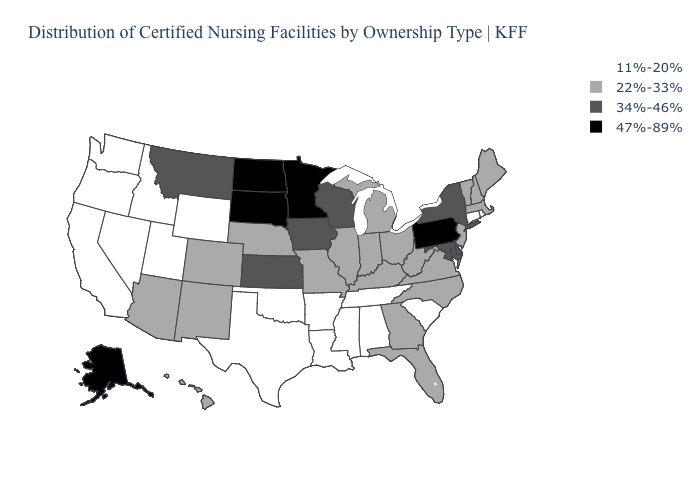What is the value of Nebraska?
Answer briefly. 22%-33%. Which states hav the highest value in the MidWest?
Answer briefly. Minnesota, North Dakota, South Dakota. What is the value of Kansas?
Answer briefly. 34%-46%. Among the states that border Ohio , which have the lowest value?
Concise answer only. Indiana, Kentucky, Michigan, West Virginia. What is the highest value in the West ?
Be succinct. 47%-89%. Name the states that have a value in the range 47%-89%?
Short answer required. Alaska, Minnesota, North Dakota, Pennsylvania, South Dakota. Does Utah have a lower value than Rhode Island?
Short answer required. No. Which states have the lowest value in the South?
Give a very brief answer. Alabama, Arkansas, Louisiana, Mississippi, Oklahoma, South Carolina, Tennessee, Texas. What is the highest value in states that border Massachusetts?
Give a very brief answer. 34%-46%. Name the states that have a value in the range 34%-46%?
Be succinct. Delaware, Iowa, Kansas, Maryland, Montana, New York, Wisconsin. Does Maine have the highest value in the Northeast?
Keep it brief. No. Name the states that have a value in the range 22%-33%?
Write a very short answer. Arizona, Colorado, Florida, Georgia, Hawaii, Illinois, Indiana, Kentucky, Maine, Massachusetts, Michigan, Missouri, Nebraska, New Hampshire, New Jersey, New Mexico, North Carolina, Ohio, Vermont, Virginia, West Virginia. Among the states that border Illinois , which have the highest value?
Give a very brief answer. Iowa, Wisconsin. What is the lowest value in the Northeast?
Keep it brief. 11%-20%. 